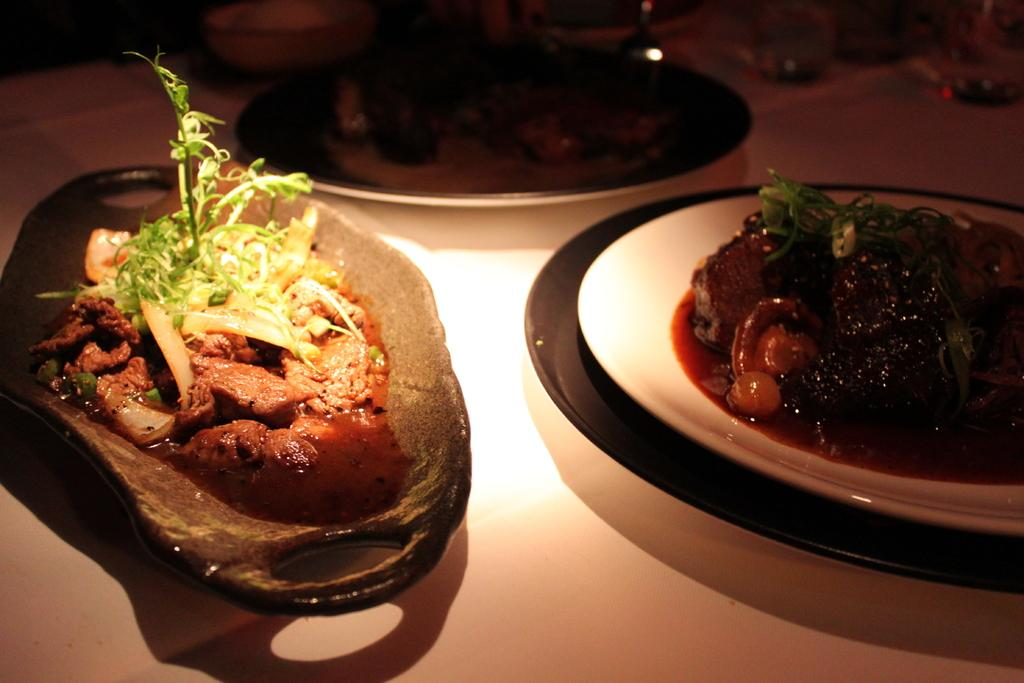What can be seen on the table in the image? There are different types of plates on the table. What is served on the plates? The plates are served with various food items. How does the spark from the journey affect the food on the plates? There is no mention of a journey or spark in the image, so it cannot be determined how they would affect the food on the plates. 